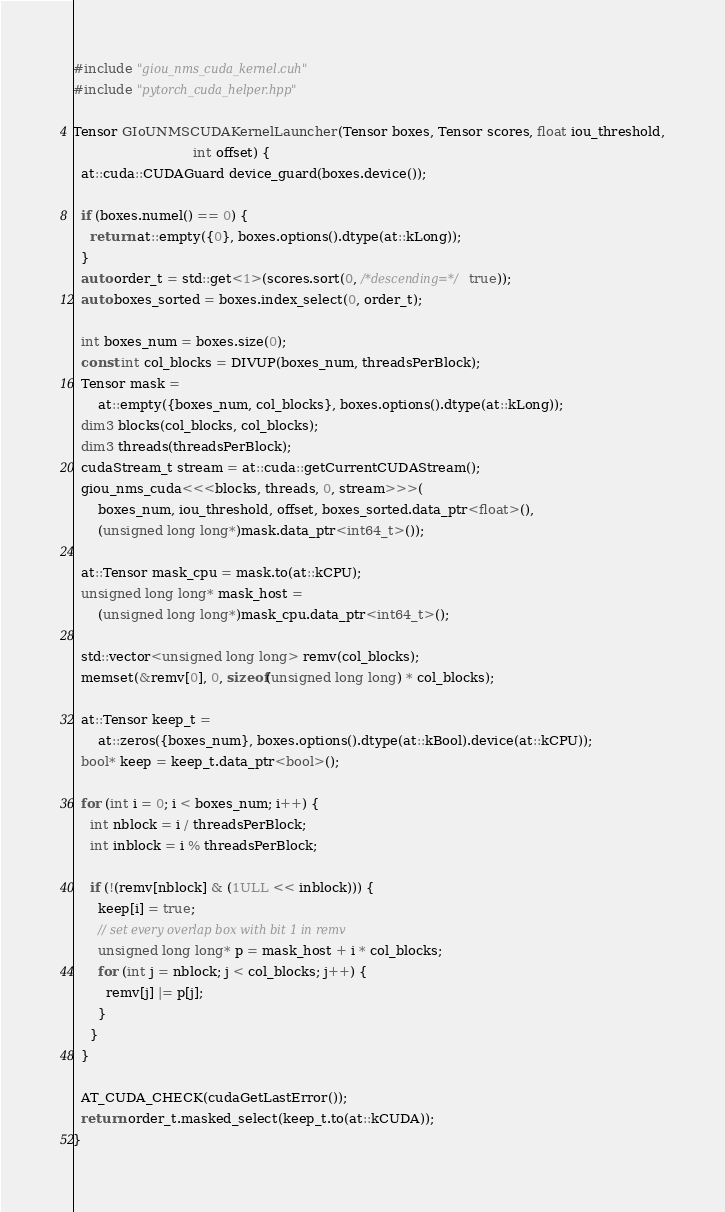<code> <loc_0><loc_0><loc_500><loc_500><_Cuda_>#include "giou_nms_cuda_kernel.cuh"
#include "pytorch_cuda_helper.hpp"

Tensor GIoUNMSCUDAKernelLauncher(Tensor boxes, Tensor scores, float iou_threshold,
                             int offset) {
  at::cuda::CUDAGuard device_guard(boxes.device());

  if (boxes.numel() == 0) {
    return at::empty({0}, boxes.options().dtype(at::kLong));
  }
  auto order_t = std::get<1>(scores.sort(0, /*descending=*/true));
  auto boxes_sorted = boxes.index_select(0, order_t);

  int boxes_num = boxes.size(0);
  const int col_blocks = DIVUP(boxes_num, threadsPerBlock);
  Tensor mask =
      at::empty({boxes_num, col_blocks}, boxes.options().dtype(at::kLong));
  dim3 blocks(col_blocks, col_blocks);
  dim3 threads(threadsPerBlock);
  cudaStream_t stream = at::cuda::getCurrentCUDAStream();
  giou_nms_cuda<<<blocks, threads, 0, stream>>>(
      boxes_num, iou_threshold, offset, boxes_sorted.data_ptr<float>(),
      (unsigned long long*)mask.data_ptr<int64_t>());

  at::Tensor mask_cpu = mask.to(at::kCPU);
  unsigned long long* mask_host =
      (unsigned long long*)mask_cpu.data_ptr<int64_t>();

  std::vector<unsigned long long> remv(col_blocks);
  memset(&remv[0], 0, sizeof(unsigned long long) * col_blocks);

  at::Tensor keep_t =
      at::zeros({boxes_num}, boxes.options().dtype(at::kBool).device(at::kCPU));
  bool* keep = keep_t.data_ptr<bool>();

  for (int i = 0; i < boxes_num; i++) {
    int nblock = i / threadsPerBlock;
    int inblock = i % threadsPerBlock;

    if (!(remv[nblock] & (1ULL << inblock))) {
      keep[i] = true;
      // set every overlap box with bit 1 in remv
      unsigned long long* p = mask_host + i * col_blocks;
      for (int j = nblock; j < col_blocks; j++) {
        remv[j] |= p[j];
      }
    }
  }

  AT_CUDA_CHECK(cudaGetLastError());
  return order_t.masked_select(keep_t.to(at::kCUDA));
}
</code> 